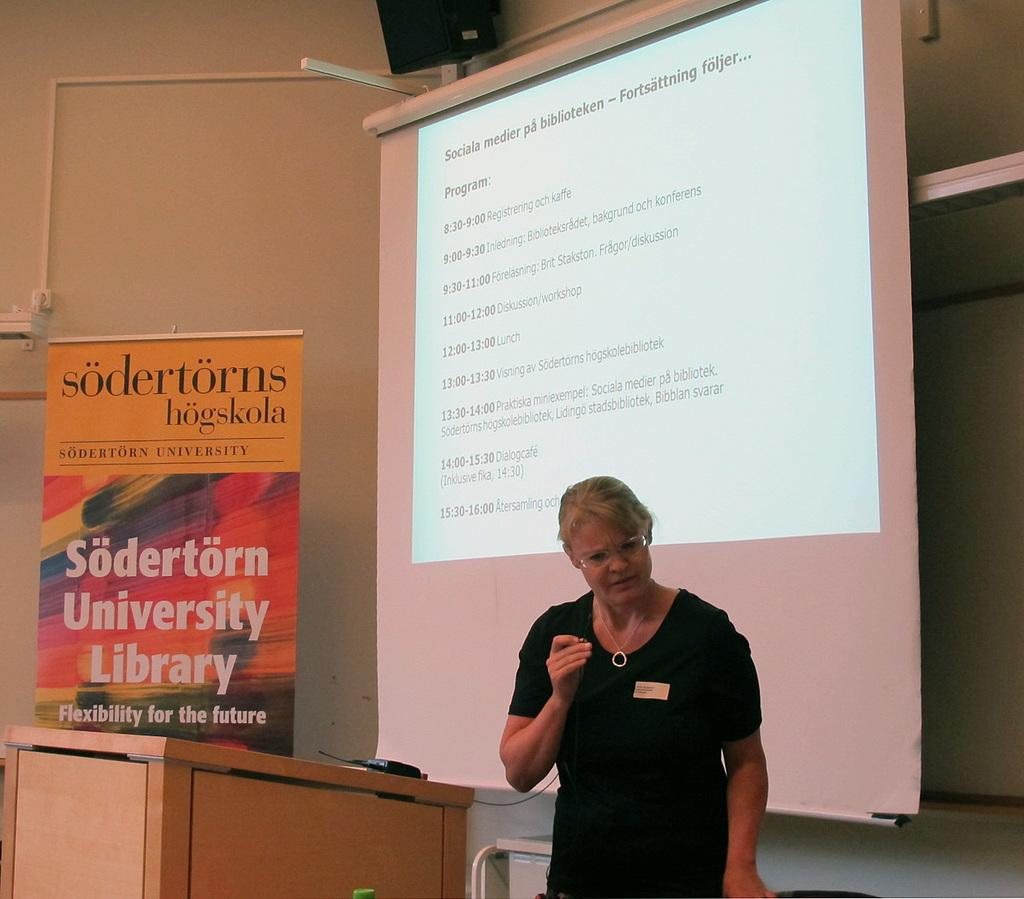<image>
Describe the image concisely. A woman is giving a presentation in front of a screen at Sodertorn University. 